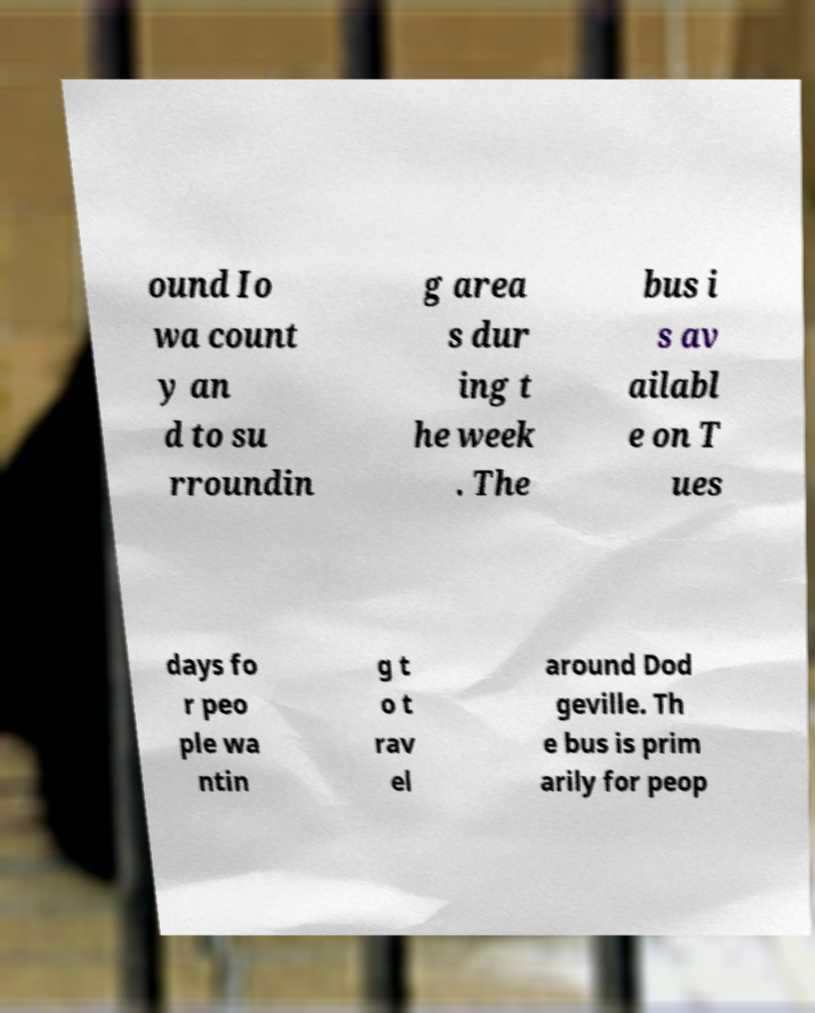Please read and relay the text visible in this image. What does it say? ound Io wa count y an d to su rroundin g area s dur ing t he week . The bus i s av ailabl e on T ues days fo r peo ple wa ntin g t o t rav el around Dod geville. Th e bus is prim arily for peop 